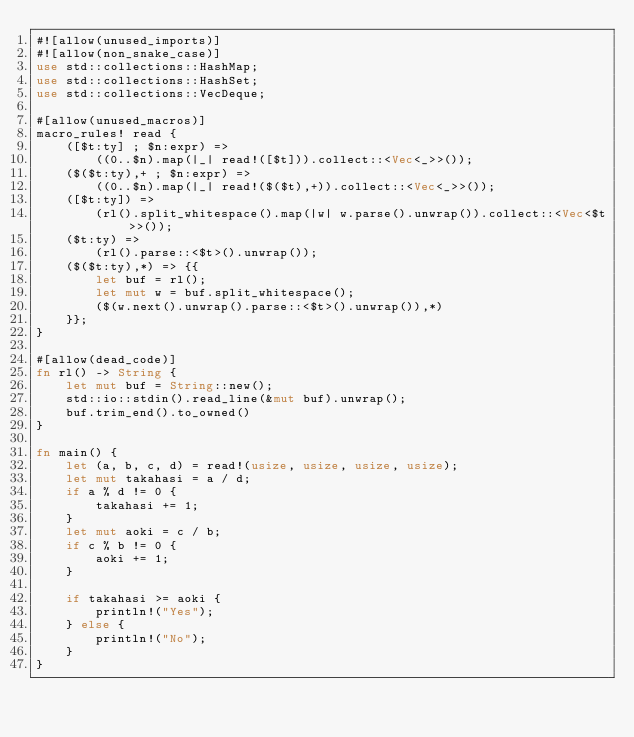<code> <loc_0><loc_0><loc_500><loc_500><_Rust_>#![allow(unused_imports)]
#![allow(non_snake_case)]
use std::collections::HashMap;
use std::collections::HashSet;
use std::collections::VecDeque;

#[allow(unused_macros)]
macro_rules! read {
    ([$t:ty] ; $n:expr) =>
        ((0..$n).map(|_| read!([$t])).collect::<Vec<_>>());
    ($($t:ty),+ ; $n:expr) =>
        ((0..$n).map(|_| read!($($t),+)).collect::<Vec<_>>());
    ([$t:ty]) =>
        (rl().split_whitespace().map(|w| w.parse().unwrap()).collect::<Vec<$t>>());
    ($t:ty) =>
        (rl().parse::<$t>().unwrap());
    ($($t:ty),*) => {{
        let buf = rl();
        let mut w = buf.split_whitespace();
        ($(w.next().unwrap().parse::<$t>().unwrap()),*)
    }};
}

#[allow(dead_code)]
fn rl() -> String {
    let mut buf = String::new();
    std::io::stdin().read_line(&mut buf).unwrap();
    buf.trim_end().to_owned()
}

fn main() {
    let (a, b, c, d) = read!(usize, usize, usize, usize);
    let mut takahasi = a / d;
    if a % d != 0 {
        takahasi += 1;
    }
    let mut aoki = c / b;
    if c % b != 0 {
        aoki += 1;
    }

    if takahasi >= aoki {
        println!("Yes");
    } else {
        println!("No");
    }
}
</code> 